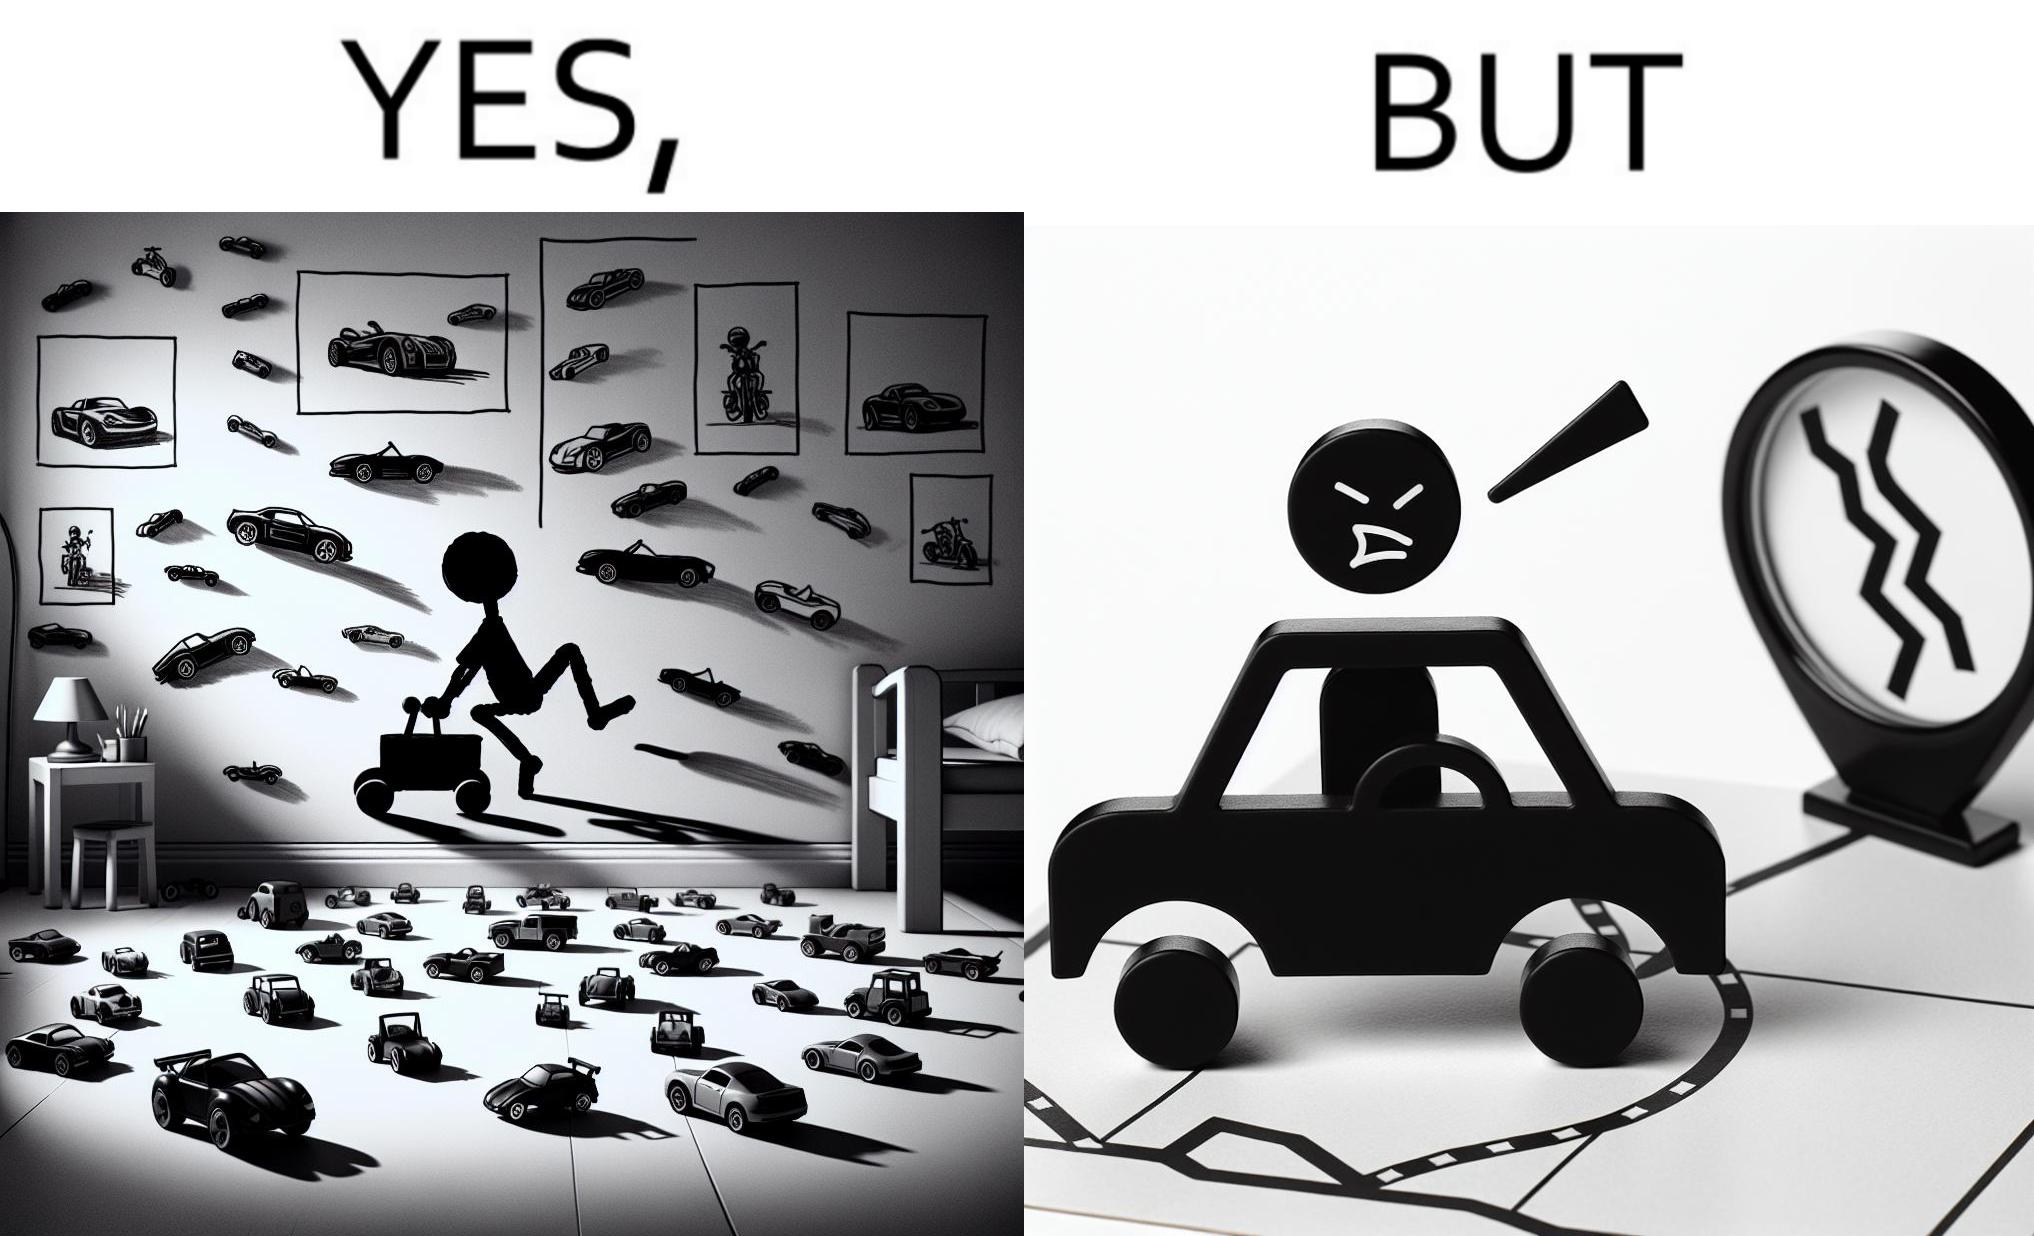Compare the left and right sides of this image. In the left part of the image: The image shows the bedroom of a child with various small toy cars and posters of cars on the wall. The child in the picture is also riding a bigger toy car. In the right part of the image: The image shows a man annoyed by the slow traffic on his way as shown on the map while he is driving. 